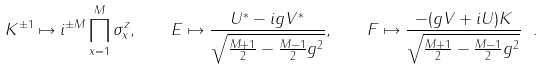<formula> <loc_0><loc_0><loc_500><loc_500>K ^ { \pm 1 } \mapsto i ^ { \pm M } \prod _ { x = 1 } ^ { M } \sigma _ { x } ^ { z } , \quad E \mapsto \frac { U ^ { \ast } - i g V ^ { \ast } } { \sqrt { \frac { M + 1 } { 2 } - \frac { M - 1 } { 2 } g ^ { 2 } } } , \quad F \mapsto \frac { - ( g V + i U ) K } { \sqrt { \frac { M + 1 } { 2 } - \frac { M - 1 } { 2 } g ^ { 2 } } } \ .</formula> 